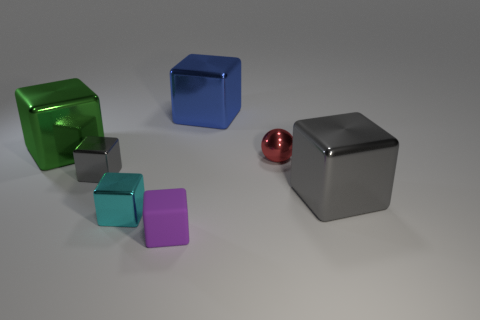Is there anything else that is made of the same material as the purple thing?
Your response must be concise. No. Are there any green metallic things in front of the gray object on the right side of the blue object?
Provide a succinct answer. No. Is the number of small gray blocks that are to the right of the tiny gray block less than the number of blue metal blocks that are on the left side of the tiny purple cube?
Give a very brief answer. No. There is a gray cube that is right of the tiny shiny thing in front of the big metal object on the right side of the small shiny ball; how big is it?
Offer a very short reply. Large. Does the metallic cube that is behind the green shiny cube have the same size as the small matte thing?
Ensure brevity in your answer.  No. How many other things are there of the same material as the sphere?
Provide a succinct answer. 5. Are there more big gray objects than small metal blocks?
Offer a terse response. No. There is a cyan cube that is in front of the small metal block behind the large metal thing to the right of the small shiny sphere; what is it made of?
Provide a short and direct response. Metal. Do the tiny matte block and the small shiny ball have the same color?
Make the answer very short. No. Are there any cylinders of the same color as the ball?
Ensure brevity in your answer.  No. 